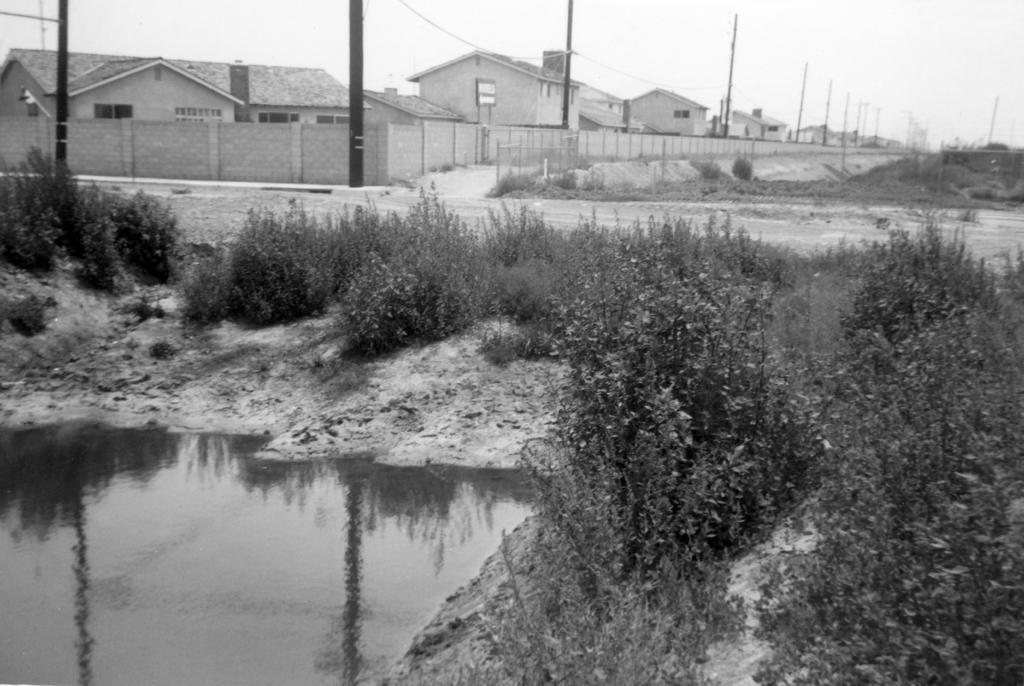Please provide a concise description of this image. This picture is in black and white. In the left bottom of the picture, we see water and this water might be in the pond. Beside that, we see trees. In the background, we see buildings, electric poles and street lights. There are trees in the background. At the top of the picture, we see the sky. 